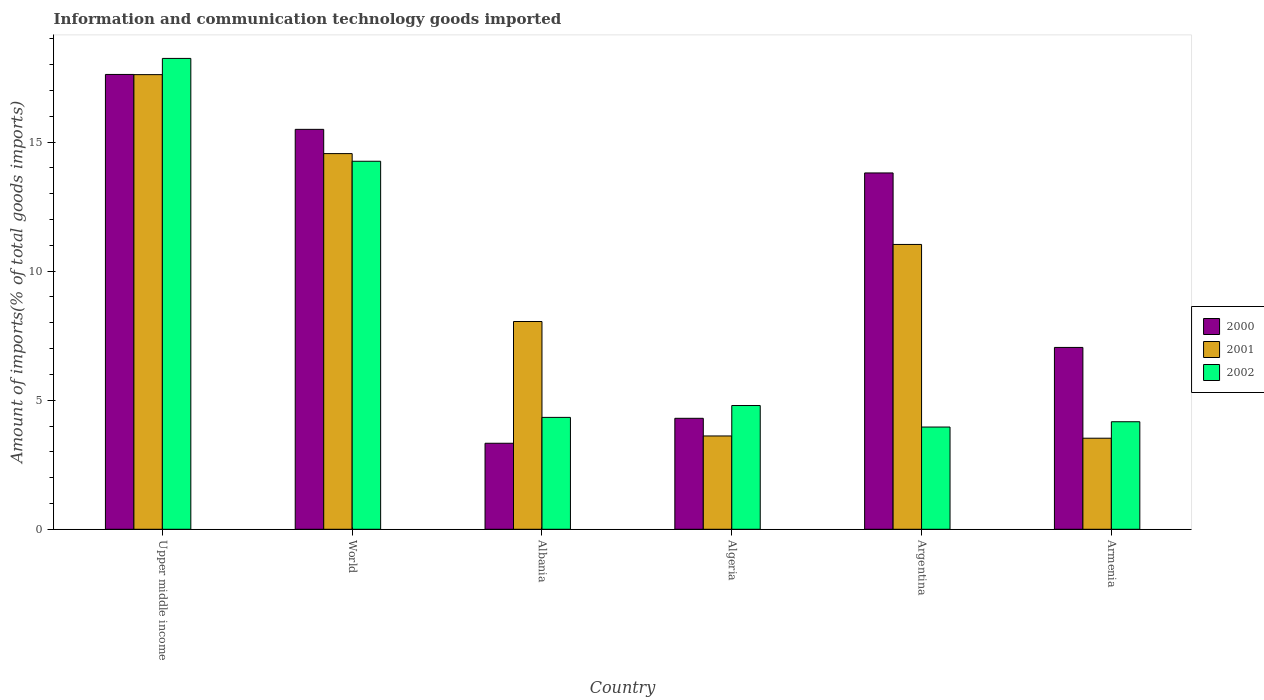Are the number of bars on each tick of the X-axis equal?
Provide a succinct answer. Yes. How many bars are there on the 4th tick from the left?
Keep it short and to the point. 3. In how many cases, is the number of bars for a given country not equal to the number of legend labels?
Make the answer very short. 0. What is the amount of goods imported in 2001 in Upper middle income?
Your response must be concise. 17.61. Across all countries, what is the maximum amount of goods imported in 2001?
Give a very brief answer. 17.61. Across all countries, what is the minimum amount of goods imported in 2000?
Provide a short and direct response. 3.33. In which country was the amount of goods imported in 2002 maximum?
Keep it short and to the point. Upper middle income. What is the total amount of goods imported in 2001 in the graph?
Ensure brevity in your answer.  58.4. What is the difference between the amount of goods imported in 2000 in Algeria and that in Argentina?
Provide a succinct answer. -9.51. What is the difference between the amount of goods imported in 2000 in World and the amount of goods imported in 2001 in Upper middle income?
Offer a terse response. -2.12. What is the average amount of goods imported in 2000 per country?
Your response must be concise. 10.27. What is the difference between the amount of goods imported of/in 2000 and amount of goods imported of/in 2002 in Algeria?
Your answer should be very brief. -0.5. In how many countries, is the amount of goods imported in 2000 greater than 17 %?
Ensure brevity in your answer.  1. What is the ratio of the amount of goods imported in 2000 in Albania to that in Armenia?
Your response must be concise. 0.47. What is the difference between the highest and the second highest amount of goods imported in 2001?
Provide a short and direct response. 6.58. What is the difference between the highest and the lowest amount of goods imported in 2000?
Ensure brevity in your answer.  14.29. How many bars are there?
Make the answer very short. 18. How many countries are there in the graph?
Your answer should be very brief. 6. Are the values on the major ticks of Y-axis written in scientific E-notation?
Offer a terse response. No. Where does the legend appear in the graph?
Provide a short and direct response. Center right. What is the title of the graph?
Keep it short and to the point. Information and communication technology goods imported. Does "1968" appear as one of the legend labels in the graph?
Offer a very short reply. No. What is the label or title of the X-axis?
Offer a very short reply. Country. What is the label or title of the Y-axis?
Provide a succinct answer. Amount of imports(% of total goods imports). What is the Amount of imports(% of total goods imports) of 2000 in Upper middle income?
Offer a very short reply. 17.62. What is the Amount of imports(% of total goods imports) of 2001 in Upper middle income?
Offer a very short reply. 17.61. What is the Amount of imports(% of total goods imports) of 2002 in Upper middle income?
Your response must be concise. 18.24. What is the Amount of imports(% of total goods imports) in 2000 in World?
Give a very brief answer. 15.49. What is the Amount of imports(% of total goods imports) of 2001 in World?
Make the answer very short. 14.56. What is the Amount of imports(% of total goods imports) of 2002 in World?
Make the answer very short. 14.26. What is the Amount of imports(% of total goods imports) of 2000 in Albania?
Ensure brevity in your answer.  3.33. What is the Amount of imports(% of total goods imports) of 2001 in Albania?
Your answer should be very brief. 8.05. What is the Amount of imports(% of total goods imports) in 2002 in Albania?
Offer a terse response. 4.34. What is the Amount of imports(% of total goods imports) in 2000 in Algeria?
Your answer should be compact. 4.3. What is the Amount of imports(% of total goods imports) in 2001 in Algeria?
Your answer should be compact. 3.62. What is the Amount of imports(% of total goods imports) of 2002 in Algeria?
Offer a terse response. 4.79. What is the Amount of imports(% of total goods imports) in 2000 in Argentina?
Your response must be concise. 13.81. What is the Amount of imports(% of total goods imports) of 2001 in Argentina?
Offer a very short reply. 11.04. What is the Amount of imports(% of total goods imports) in 2002 in Argentina?
Ensure brevity in your answer.  3.96. What is the Amount of imports(% of total goods imports) in 2000 in Armenia?
Provide a short and direct response. 7.05. What is the Amount of imports(% of total goods imports) of 2001 in Armenia?
Give a very brief answer. 3.53. What is the Amount of imports(% of total goods imports) of 2002 in Armenia?
Your response must be concise. 4.17. Across all countries, what is the maximum Amount of imports(% of total goods imports) in 2000?
Provide a short and direct response. 17.62. Across all countries, what is the maximum Amount of imports(% of total goods imports) of 2001?
Provide a succinct answer. 17.61. Across all countries, what is the maximum Amount of imports(% of total goods imports) of 2002?
Offer a terse response. 18.24. Across all countries, what is the minimum Amount of imports(% of total goods imports) of 2000?
Offer a terse response. 3.33. Across all countries, what is the minimum Amount of imports(% of total goods imports) in 2001?
Offer a very short reply. 3.53. Across all countries, what is the minimum Amount of imports(% of total goods imports) in 2002?
Offer a terse response. 3.96. What is the total Amount of imports(% of total goods imports) in 2000 in the graph?
Your answer should be compact. 61.6. What is the total Amount of imports(% of total goods imports) of 2001 in the graph?
Provide a succinct answer. 58.4. What is the total Amount of imports(% of total goods imports) of 2002 in the graph?
Ensure brevity in your answer.  49.76. What is the difference between the Amount of imports(% of total goods imports) of 2000 in Upper middle income and that in World?
Your answer should be compact. 2.13. What is the difference between the Amount of imports(% of total goods imports) of 2001 in Upper middle income and that in World?
Your answer should be compact. 3.06. What is the difference between the Amount of imports(% of total goods imports) in 2002 in Upper middle income and that in World?
Make the answer very short. 3.98. What is the difference between the Amount of imports(% of total goods imports) in 2000 in Upper middle income and that in Albania?
Your answer should be compact. 14.29. What is the difference between the Amount of imports(% of total goods imports) of 2001 in Upper middle income and that in Albania?
Ensure brevity in your answer.  9.57. What is the difference between the Amount of imports(% of total goods imports) in 2002 in Upper middle income and that in Albania?
Offer a very short reply. 13.91. What is the difference between the Amount of imports(% of total goods imports) of 2000 in Upper middle income and that in Algeria?
Provide a short and direct response. 13.32. What is the difference between the Amount of imports(% of total goods imports) of 2001 in Upper middle income and that in Algeria?
Offer a terse response. 14. What is the difference between the Amount of imports(% of total goods imports) of 2002 in Upper middle income and that in Algeria?
Make the answer very short. 13.45. What is the difference between the Amount of imports(% of total goods imports) in 2000 in Upper middle income and that in Argentina?
Your answer should be very brief. 3.82. What is the difference between the Amount of imports(% of total goods imports) in 2001 in Upper middle income and that in Argentina?
Provide a short and direct response. 6.58. What is the difference between the Amount of imports(% of total goods imports) of 2002 in Upper middle income and that in Argentina?
Provide a short and direct response. 14.28. What is the difference between the Amount of imports(% of total goods imports) in 2000 in Upper middle income and that in Armenia?
Make the answer very short. 10.58. What is the difference between the Amount of imports(% of total goods imports) in 2001 in Upper middle income and that in Armenia?
Offer a very short reply. 14.09. What is the difference between the Amount of imports(% of total goods imports) in 2002 in Upper middle income and that in Armenia?
Provide a succinct answer. 14.08. What is the difference between the Amount of imports(% of total goods imports) of 2000 in World and that in Albania?
Ensure brevity in your answer.  12.16. What is the difference between the Amount of imports(% of total goods imports) of 2001 in World and that in Albania?
Offer a terse response. 6.51. What is the difference between the Amount of imports(% of total goods imports) of 2002 in World and that in Albania?
Offer a terse response. 9.92. What is the difference between the Amount of imports(% of total goods imports) of 2000 in World and that in Algeria?
Offer a terse response. 11.2. What is the difference between the Amount of imports(% of total goods imports) of 2001 in World and that in Algeria?
Offer a terse response. 10.94. What is the difference between the Amount of imports(% of total goods imports) of 2002 in World and that in Algeria?
Your response must be concise. 9.46. What is the difference between the Amount of imports(% of total goods imports) of 2000 in World and that in Argentina?
Offer a terse response. 1.69. What is the difference between the Amount of imports(% of total goods imports) in 2001 in World and that in Argentina?
Your answer should be very brief. 3.52. What is the difference between the Amount of imports(% of total goods imports) in 2002 in World and that in Argentina?
Your answer should be compact. 10.3. What is the difference between the Amount of imports(% of total goods imports) in 2000 in World and that in Armenia?
Ensure brevity in your answer.  8.45. What is the difference between the Amount of imports(% of total goods imports) of 2001 in World and that in Armenia?
Your response must be concise. 11.03. What is the difference between the Amount of imports(% of total goods imports) in 2002 in World and that in Armenia?
Give a very brief answer. 10.09. What is the difference between the Amount of imports(% of total goods imports) of 2000 in Albania and that in Algeria?
Offer a very short reply. -0.97. What is the difference between the Amount of imports(% of total goods imports) of 2001 in Albania and that in Algeria?
Give a very brief answer. 4.43. What is the difference between the Amount of imports(% of total goods imports) of 2002 in Albania and that in Algeria?
Keep it short and to the point. -0.46. What is the difference between the Amount of imports(% of total goods imports) of 2000 in Albania and that in Argentina?
Ensure brevity in your answer.  -10.47. What is the difference between the Amount of imports(% of total goods imports) of 2001 in Albania and that in Argentina?
Ensure brevity in your answer.  -2.99. What is the difference between the Amount of imports(% of total goods imports) of 2002 in Albania and that in Argentina?
Your answer should be compact. 0.37. What is the difference between the Amount of imports(% of total goods imports) of 2000 in Albania and that in Armenia?
Your answer should be compact. -3.71. What is the difference between the Amount of imports(% of total goods imports) in 2001 in Albania and that in Armenia?
Offer a terse response. 4.52. What is the difference between the Amount of imports(% of total goods imports) of 2002 in Albania and that in Armenia?
Give a very brief answer. 0.17. What is the difference between the Amount of imports(% of total goods imports) in 2000 in Algeria and that in Argentina?
Give a very brief answer. -9.51. What is the difference between the Amount of imports(% of total goods imports) in 2001 in Algeria and that in Argentina?
Your answer should be very brief. -7.42. What is the difference between the Amount of imports(% of total goods imports) of 2002 in Algeria and that in Argentina?
Your answer should be compact. 0.83. What is the difference between the Amount of imports(% of total goods imports) of 2000 in Algeria and that in Armenia?
Your response must be concise. -2.75. What is the difference between the Amount of imports(% of total goods imports) in 2001 in Algeria and that in Armenia?
Your response must be concise. 0.09. What is the difference between the Amount of imports(% of total goods imports) of 2002 in Algeria and that in Armenia?
Offer a terse response. 0.63. What is the difference between the Amount of imports(% of total goods imports) of 2000 in Argentina and that in Armenia?
Provide a short and direct response. 6.76. What is the difference between the Amount of imports(% of total goods imports) of 2001 in Argentina and that in Armenia?
Give a very brief answer. 7.51. What is the difference between the Amount of imports(% of total goods imports) of 2002 in Argentina and that in Armenia?
Your response must be concise. -0.2. What is the difference between the Amount of imports(% of total goods imports) in 2000 in Upper middle income and the Amount of imports(% of total goods imports) in 2001 in World?
Provide a succinct answer. 3.07. What is the difference between the Amount of imports(% of total goods imports) of 2000 in Upper middle income and the Amount of imports(% of total goods imports) of 2002 in World?
Make the answer very short. 3.36. What is the difference between the Amount of imports(% of total goods imports) of 2001 in Upper middle income and the Amount of imports(% of total goods imports) of 2002 in World?
Offer a very short reply. 3.36. What is the difference between the Amount of imports(% of total goods imports) of 2000 in Upper middle income and the Amount of imports(% of total goods imports) of 2001 in Albania?
Offer a terse response. 9.57. What is the difference between the Amount of imports(% of total goods imports) in 2000 in Upper middle income and the Amount of imports(% of total goods imports) in 2002 in Albania?
Give a very brief answer. 13.29. What is the difference between the Amount of imports(% of total goods imports) of 2001 in Upper middle income and the Amount of imports(% of total goods imports) of 2002 in Albania?
Keep it short and to the point. 13.28. What is the difference between the Amount of imports(% of total goods imports) of 2000 in Upper middle income and the Amount of imports(% of total goods imports) of 2001 in Algeria?
Keep it short and to the point. 14.01. What is the difference between the Amount of imports(% of total goods imports) of 2000 in Upper middle income and the Amount of imports(% of total goods imports) of 2002 in Algeria?
Make the answer very short. 12.83. What is the difference between the Amount of imports(% of total goods imports) in 2001 in Upper middle income and the Amount of imports(% of total goods imports) in 2002 in Algeria?
Offer a terse response. 12.82. What is the difference between the Amount of imports(% of total goods imports) in 2000 in Upper middle income and the Amount of imports(% of total goods imports) in 2001 in Argentina?
Provide a succinct answer. 6.59. What is the difference between the Amount of imports(% of total goods imports) of 2000 in Upper middle income and the Amount of imports(% of total goods imports) of 2002 in Argentina?
Your response must be concise. 13.66. What is the difference between the Amount of imports(% of total goods imports) in 2001 in Upper middle income and the Amount of imports(% of total goods imports) in 2002 in Argentina?
Keep it short and to the point. 13.65. What is the difference between the Amount of imports(% of total goods imports) in 2000 in Upper middle income and the Amount of imports(% of total goods imports) in 2001 in Armenia?
Give a very brief answer. 14.09. What is the difference between the Amount of imports(% of total goods imports) in 2000 in Upper middle income and the Amount of imports(% of total goods imports) in 2002 in Armenia?
Provide a short and direct response. 13.46. What is the difference between the Amount of imports(% of total goods imports) in 2001 in Upper middle income and the Amount of imports(% of total goods imports) in 2002 in Armenia?
Offer a very short reply. 13.45. What is the difference between the Amount of imports(% of total goods imports) in 2000 in World and the Amount of imports(% of total goods imports) in 2001 in Albania?
Keep it short and to the point. 7.44. What is the difference between the Amount of imports(% of total goods imports) in 2000 in World and the Amount of imports(% of total goods imports) in 2002 in Albania?
Offer a very short reply. 11.16. What is the difference between the Amount of imports(% of total goods imports) of 2001 in World and the Amount of imports(% of total goods imports) of 2002 in Albania?
Provide a short and direct response. 10.22. What is the difference between the Amount of imports(% of total goods imports) of 2000 in World and the Amount of imports(% of total goods imports) of 2001 in Algeria?
Offer a very short reply. 11.88. What is the difference between the Amount of imports(% of total goods imports) in 2000 in World and the Amount of imports(% of total goods imports) in 2002 in Algeria?
Offer a terse response. 10.7. What is the difference between the Amount of imports(% of total goods imports) in 2001 in World and the Amount of imports(% of total goods imports) in 2002 in Algeria?
Your response must be concise. 9.76. What is the difference between the Amount of imports(% of total goods imports) in 2000 in World and the Amount of imports(% of total goods imports) in 2001 in Argentina?
Your response must be concise. 4.46. What is the difference between the Amount of imports(% of total goods imports) in 2000 in World and the Amount of imports(% of total goods imports) in 2002 in Argentina?
Provide a short and direct response. 11.53. What is the difference between the Amount of imports(% of total goods imports) in 2001 in World and the Amount of imports(% of total goods imports) in 2002 in Argentina?
Your answer should be compact. 10.59. What is the difference between the Amount of imports(% of total goods imports) of 2000 in World and the Amount of imports(% of total goods imports) of 2001 in Armenia?
Make the answer very short. 11.97. What is the difference between the Amount of imports(% of total goods imports) in 2000 in World and the Amount of imports(% of total goods imports) in 2002 in Armenia?
Ensure brevity in your answer.  11.33. What is the difference between the Amount of imports(% of total goods imports) in 2001 in World and the Amount of imports(% of total goods imports) in 2002 in Armenia?
Provide a succinct answer. 10.39. What is the difference between the Amount of imports(% of total goods imports) of 2000 in Albania and the Amount of imports(% of total goods imports) of 2001 in Algeria?
Offer a very short reply. -0.28. What is the difference between the Amount of imports(% of total goods imports) of 2000 in Albania and the Amount of imports(% of total goods imports) of 2002 in Algeria?
Ensure brevity in your answer.  -1.46. What is the difference between the Amount of imports(% of total goods imports) of 2001 in Albania and the Amount of imports(% of total goods imports) of 2002 in Algeria?
Your answer should be compact. 3.25. What is the difference between the Amount of imports(% of total goods imports) of 2000 in Albania and the Amount of imports(% of total goods imports) of 2001 in Argentina?
Your response must be concise. -7.7. What is the difference between the Amount of imports(% of total goods imports) of 2000 in Albania and the Amount of imports(% of total goods imports) of 2002 in Argentina?
Your response must be concise. -0.63. What is the difference between the Amount of imports(% of total goods imports) of 2001 in Albania and the Amount of imports(% of total goods imports) of 2002 in Argentina?
Your answer should be very brief. 4.09. What is the difference between the Amount of imports(% of total goods imports) in 2000 in Albania and the Amount of imports(% of total goods imports) in 2001 in Armenia?
Give a very brief answer. -0.2. What is the difference between the Amount of imports(% of total goods imports) in 2000 in Albania and the Amount of imports(% of total goods imports) in 2002 in Armenia?
Your answer should be compact. -0.83. What is the difference between the Amount of imports(% of total goods imports) in 2001 in Albania and the Amount of imports(% of total goods imports) in 2002 in Armenia?
Offer a very short reply. 3.88. What is the difference between the Amount of imports(% of total goods imports) of 2000 in Algeria and the Amount of imports(% of total goods imports) of 2001 in Argentina?
Keep it short and to the point. -6.74. What is the difference between the Amount of imports(% of total goods imports) of 2000 in Algeria and the Amount of imports(% of total goods imports) of 2002 in Argentina?
Your answer should be very brief. 0.34. What is the difference between the Amount of imports(% of total goods imports) of 2001 in Algeria and the Amount of imports(% of total goods imports) of 2002 in Argentina?
Keep it short and to the point. -0.35. What is the difference between the Amount of imports(% of total goods imports) in 2000 in Algeria and the Amount of imports(% of total goods imports) in 2001 in Armenia?
Keep it short and to the point. 0.77. What is the difference between the Amount of imports(% of total goods imports) in 2000 in Algeria and the Amount of imports(% of total goods imports) in 2002 in Armenia?
Make the answer very short. 0.13. What is the difference between the Amount of imports(% of total goods imports) of 2001 in Algeria and the Amount of imports(% of total goods imports) of 2002 in Armenia?
Your answer should be very brief. -0.55. What is the difference between the Amount of imports(% of total goods imports) in 2000 in Argentina and the Amount of imports(% of total goods imports) in 2001 in Armenia?
Your response must be concise. 10.28. What is the difference between the Amount of imports(% of total goods imports) of 2000 in Argentina and the Amount of imports(% of total goods imports) of 2002 in Armenia?
Your answer should be very brief. 9.64. What is the difference between the Amount of imports(% of total goods imports) of 2001 in Argentina and the Amount of imports(% of total goods imports) of 2002 in Armenia?
Your answer should be very brief. 6.87. What is the average Amount of imports(% of total goods imports) in 2000 per country?
Provide a succinct answer. 10.27. What is the average Amount of imports(% of total goods imports) of 2001 per country?
Offer a very short reply. 9.73. What is the average Amount of imports(% of total goods imports) in 2002 per country?
Your answer should be very brief. 8.29. What is the difference between the Amount of imports(% of total goods imports) in 2000 and Amount of imports(% of total goods imports) in 2001 in Upper middle income?
Your response must be concise. 0.01. What is the difference between the Amount of imports(% of total goods imports) of 2000 and Amount of imports(% of total goods imports) of 2002 in Upper middle income?
Provide a short and direct response. -0.62. What is the difference between the Amount of imports(% of total goods imports) in 2001 and Amount of imports(% of total goods imports) in 2002 in Upper middle income?
Offer a terse response. -0.63. What is the difference between the Amount of imports(% of total goods imports) of 2000 and Amount of imports(% of total goods imports) of 2001 in World?
Your answer should be very brief. 0.94. What is the difference between the Amount of imports(% of total goods imports) in 2000 and Amount of imports(% of total goods imports) in 2002 in World?
Provide a succinct answer. 1.24. What is the difference between the Amount of imports(% of total goods imports) in 2001 and Amount of imports(% of total goods imports) in 2002 in World?
Offer a terse response. 0.3. What is the difference between the Amount of imports(% of total goods imports) of 2000 and Amount of imports(% of total goods imports) of 2001 in Albania?
Provide a succinct answer. -4.72. What is the difference between the Amount of imports(% of total goods imports) of 2000 and Amount of imports(% of total goods imports) of 2002 in Albania?
Your response must be concise. -1. What is the difference between the Amount of imports(% of total goods imports) in 2001 and Amount of imports(% of total goods imports) in 2002 in Albania?
Ensure brevity in your answer.  3.71. What is the difference between the Amount of imports(% of total goods imports) in 2000 and Amount of imports(% of total goods imports) in 2001 in Algeria?
Your answer should be very brief. 0.68. What is the difference between the Amount of imports(% of total goods imports) of 2000 and Amount of imports(% of total goods imports) of 2002 in Algeria?
Your answer should be compact. -0.5. What is the difference between the Amount of imports(% of total goods imports) in 2001 and Amount of imports(% of total goods imports) in 2002 in Algeria?
Ensure brevity in your answer.  -1.18. What is the difference between the Amount of imports(% of total goods imports) in 2000 and Amount of imports(% of total goods imports) in 2001 in Argentina?
Ensure brevity in your answer.  2.77. What is the difference between the Amount of imports(% of total goods imports) in 2000 and Amount of imports(% of total goods imports) in 2002 in Argentina?
Your answer should be compact. 9.84. What is the difference between the Amount of imports(% of total goods imports) in 2001 and Amount of imports(% of total goods imports) in 2002 in Argentina?
Offer a terse response. 7.07. What is the difference between the Amount of imports(% of total goods imports) of 2000 and Amount of imports(% of total goods imports) of 2001 in Armenia?
Provide a short and direct response. 3.52. What is the difference between the Amount of imports(% of total goods imports) in 2000 and Amount of imports(% of total goods imports) in 2002 in Armenia?
Provide a succinct answer. 2.88. What is the difference between the Amount of imports(% of total goods imports) of 2001 and Amount of imports(% of total goods imports) of 2002 in Armenia?
Make the answer very short. -0.64. What is the ratio of the Amount of imports(% of total goods imports) of 2000 in Upper middle income to that in World?
Provide a succinct answer. 1.14. What is the ratio of the Amount of imports(% of total goods imports) in 2001 in Upper middle income to that in World?
Provide a succinct answer. 1.21. What is the ratio of the Amount of imports(% of total goods imports) in 2002 in Upper middle income to that in World?
Offer a terse response. 1.28. What is the ratio of the Amount of imports(% of total goods imports) of 2000 in Upper middle income to that in Albania?
Offer a very short reply. 5.29. What is the ratio of the Amount of imports(% of total goods imports) of 2001 in Upper middle income to that in Albania?
Make the answer very short. 2.19. What is the ratio of the Amount of imports(% of total goods imports) of 2002 in Upper middle income to that in Albania?
Keep it short and to the point. 4.21. What is the ratio of the Amount of imports(% of total goods imports) of 2000 in Upper middle income to that in Algeria?
Provide a short and direct response. 4.1. What is the ratio of the Amount of imports(% of total goods imports) in 2001 in Upper middle income to that in Algeria?
Offer a terse response. 4.87. What is the ratio of the Amount of imports(% of total goods imports) of 2002 in Upper middle income to that in Algeria?
Your answer should be very brief. 3.8. What is the ratio of the Amount of imports(% of total goods imports) in 2000 in Upper middle income to that in Argentina?
Provide a short and direct response. 1.28. What is the ratio of the Amount of imports(% of total goods imports) in 2001 in Upper middle income to that in Argentina?
Make the answer very short. 1.6. What is the ratio of the Amount of imports(% of total goods imports) in 2002 in Upper middle income to that in Argentina?
Ensure brevity in your answer.  4.61. What is the ratio of the Amount of imports(% of total goods imports) of 2000 in Upper middle income to that in Armenia?
Provide a short and direct response. 2.5. What is the ratio of the Amount of imports(% of total goods imports) of 2001 in Upper middle income to that in Armenia?
Your answer should be compact. 4.99. What is the ratio of the Amount of imports(% of total goods imports) in 2002 in Upper middle income to that in Armenia?
Your response must be concise. 4.38. What is the ratio of the Amount of imports(% of total goods imports) of 2000 in World to that in Albania?
Give a very brief answer. 4.65. What is the ratio of the Amount of imports(% of total goods imports) in 2001 in World to that in Albania?
Offer a very short reply. 1.81. What is the ratio of the Amount of imports(% of total goods imports) of 2002 in World to that in Albania?
Keep it short and to the point. 3.29. What is the ratio of the Amount of imports(% of total goods imports) of 2000 in World to that in Algeria?
Make the answer very short. 3.6. What is the ratio of the Amount of imports(% of total goods imports) of 2001 in World to that in Algeria?
Make the answer very short. 4.03. What is the ratio of the Amount of imports(% of total goods imports) of 2002 in World to that in Algeria?
Your response must be concise. 2.97. What is the ratio of the Amount of imports(% of total goods imports) in 2000 in World to that in Argentina?
Make the answer very short. 1.12. What is the ratio of the Amount of imports(% of total goods imports) in 2001 in World to that in Argentina?
Your answer should be compact. 1.32. What is the ratio of the Amount of imports(% of total goods imports) in 2002 in World to that in Argentina?
Make the answer very short. 3.6. What is the ratio of the Amount of imports(% of total goods imports) in 2000 in World to that in Armenia?
Offer a very short reply. 2.2. What is the ratio of the Amount of imports(% of total goods imports) of 2001 in World to that in Armenia?
Give a very brief answer. 4.13. What is the ratio of the Amount of imports(% of total goods imports) in 2002 in World to that in Armenia?
Provide a succinct answer. 3.42. What is the ratio of the Amount of imports(% of total goods imports) in 2000 in Albania to that in Algeria?
Give a very brief answer. 0.78. What is the ratio of the Amount of imports(% of total goods imports) in 2001 in Albania to that in Algeria?
Make the answer very short. 2.23. What is the ratio of the Amount of imports(% of total goods imports) in 2002 in Albania to that in Algeria?
Offer a terse response. 0.9. What is the ratio of the Amount of imports(% of total goods imports) of 2000 in Albania to that in Argentina?
Offer a very short reply. 0.24. What is the ratio of the Amount of imports(% of total goods imports) in 2001 in Albania to that in Argentina?
Provide a succinct answer. 0.73. What is the ratio of the Amount of imports(% of total goods imports) of 2002 in Albania to that in Argentina?
Your response must be concise. 1.09. What is the ratio of the Amount of imports(% of total goods imports) in 2000 in Albania to that in Armenia?
Your answer should be very brief. 0.47. What is the ratio of the Amount of imports(% of total goods imports) of 2001 in Albania to that in Armenia?
Your answer should be very brief. 2.28. What is the ratio of the Amount of imports(% of total goods imports) of 2002 in Albania to that in Armenia?
Provide a short and direct response. 1.04. What is the ratio of the Amount of imports(% of total goods imports) in 2000 in Algeria to that in Argentina?
Offer a very short reply. 0.31. What is the ratio of the Amount of imports(% of total goods imports) of 2001 in Algeria to that in Argentina?
Make the answer very short. 0.33. What is the ratio of the Amount of imports(% of total goods imports) of 2002 in Algeria to that in Argentina?
Keep it short and to the point. 1.21. What is the ratio of the Amount of imports(% of total goods imports) of 2000 in Algeria to that in Armenia?
Ensure brevity in your answer.  0.61. What is the ratio of the Amount of imports(% of total goods imports) in 2001 in Algeria to that in Armenia?
Ensure brevity in your answer.  1.02. What is the ratio of the Amount of imports(% of total goods imports) in 2002 in Algeria to that in Armenia?
Offer a very short reply. 1.15. What is the ratio of the Amount of imports(% of total goods imports) of 2000 in Argentina to that in Armenia?
Provide a short and direct response. 1.96. What is the ratio of the Amount of imports(% of total goods imports) of 2001 in Argentina to that in Armenia?
Ensure brevity in your answer.  3.13. What is the ratio of the Amount of imports(% of total goods imports) in 2002 in Argentina to that in Armenia?
Your response must be concise. 0.95. What is the difference between the highest and the second highest Amount of imports(% of total goods imports) in 2000?
Your answer should be compact. 2.13. What is the difference between the highest and the second highest Amount of imports(% of total goods imports) of 2001?
Ensure brevity in your answer.  3.06. What is the difference between the highest and the second highest Amount of imports(% of total goods imports) in 2002?
Offer a terse response. 3.98. What is the difference between the highest and the lowest Amount of imports(% of total goods imports) in 2000?
Provide a short and direct response. 14.29. What is the difference between the highest and the lowest Amount of imports(% of total goods imports) of 2001?
Offer a very short reply. 14.09. What is the difference between the highest and the lowest Amount of imports(% of total goods imports) of 2002?
Ensure brevity in your answer.  14.28. 